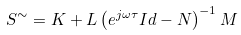Convert formula to latex. <formula><loc_0><loc_0><loc_500><loc_500>S ^ { \sim } = K + L \left ( e ^ { j \omega \tau } I d - N \right ) ^ { - 1 } M</formula> 